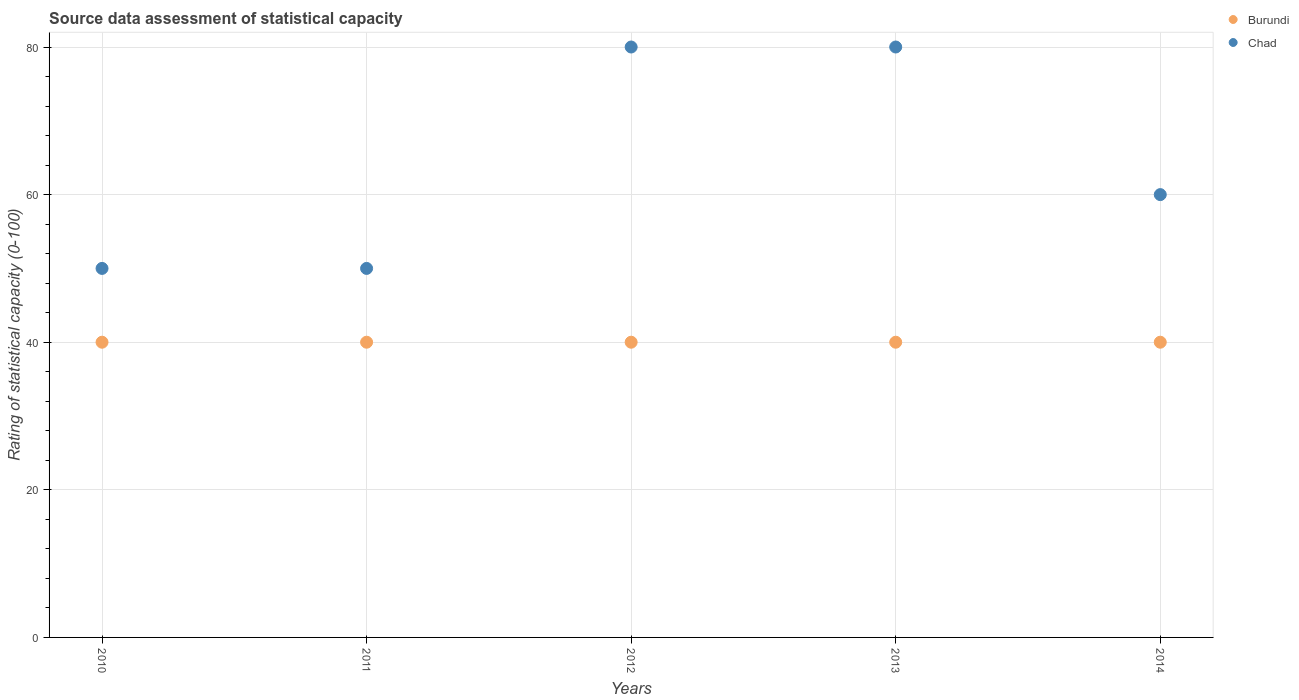How many different coloured dotlines are there?
Your response must be concise. 2. What is the rating of statistical capacity in Burundi in 2013?
Keep it short and to the point. 40. Across all years, what is the maximum rating of statistical capacity in Chad?
Your answer should be compact. 80. Across all years, what is the minimum rating of statistical capacity in Chad?
Provide a short and direct response. 50. In which year was the rating of statistical capacity in Chad minimum?
Your answer should be compact. 2010. What is the total rating of statistical capacity in Burundi in the graph?
Your answer should be compact. 200. What is the difference between the rating of statistical capacity in Chad in 2011 and that in 2014?
Your answer should be very brief. -10. What is the difference between the rating of statistical capacity in Burundi in 2011 and the rating of statistical capacity in Chad in 2010?
Make the answer very short. -10. In the year 2014, what is the difference between the rating of statistical capacity in Burundi and rating of statistical capacity in Chad?
Keep it short and to the point. -20. In how many years, is the rating of statistical capacity in Chad greater than 12?
Your response must be concise. 5. What is the difference between the highest and the lowest rating of statistical capacity in Chad?
Offer a terse response. 30. In how many years, is the rating of statistical capacity in Chad greater than the average rating of statistical capacity in Chad taken over all years?
Offer a terse response. 2. Does the rating of statistical capacity in Burundi monotonically increase over the years?
Keep it short and to the point. No. Is the rating of statistical capacity in Burundi strictly greater than the rating of statistical capacity in Chad over the years?
Your answer should be compact. No. How many dotlines are there?
Give a very brief answer. 2. How many years are there in the graph?
Keep it short and to the point. 5. Does the graph contain grids?
Provide a short and direct response. Yes. How many legend labels are there?
Your answer should be very brief. 2. What is the title of the graph?
Provide a succinct answer. Source data assessment of statistical capacity. Does "Afghanistan" appear as one of the legend labels in the graph?
Keep it short and to the point. No. What is the label or title of the Y-axis?
Provide a succinct answer. Rating of statistical capacity (0-100). What is the Rating of statistical capacity (0-100) of Chad in 2010?
Your answer should be compact. 50. What is the Rating of statistical capacity (0-100) of Burundi in 2011?
Provide a short and direct response. 40. What is the Rating of statistical capacity (0-100) of Chad in 2011?
Offer a terse response. 50. What is the Rating of statistical capacity (0-100) of Burundi in 2012?
Keep it short and to the point. 40. What is the Rating of statistical capacity (0-100) in Burundi in 2013?
Your answer should be very brief. 40. What is the Rating of statistical capacity (0-100) of Chad in 2013?
Offer a terse response. 80. What is the Rating of statistical capacity (0-100) of Burundi in 2014?
Provide a succinct answer. 40. Across all years, what is the maximum Rating of statistical capacity (0-100) of Burundi?
Your answer should be compact. 40. Across all years, what is the maximum Rating of statistical capacity (0-100) in Chad?
Provide a short and direct response. 80. Across all years, what is the minimum Rating of statistical capacity (0-100) of Chad?
Provide a succinct answer. 50. What is the total Rating of statistical capacity (0-100) of Chad in the graph?
Make the answer very short. 320. What is the difference between the Rating of statistical capacity (0-100) in Burundi in 2010 and that in 2011?
Keep it short and to the point. 0. What is the difference between the Rating of statistical capacity (0-100) in Burundi in 2010 and that in 2012?
Your answer should be very brief. 0. What is the difference between the Rating of statistical capacity (0-100) of Burundi in 2010 and that in 2013?
Offer a terse response. 0. What is the difference between the Rating of statistical capacity (0-100) in Chad in 2010 and that in 2013?
Your answer should be compact. -30. What is the difference between the Rating of statistical capacity (0-100) in Chad in 2010 and that in 2014?
Provide a succinct answer. -10. What is the difference between the Rating of statistical capacity (0-100) in Chad in 2011 and that in 2013?
Your answer should be compact. -30. What is the difference between the Rating of statistical capacity (0-100) of Burundi in 2011 and that in 2014?
Keep it short and to the point. 0. What is the difference between the Rating of statistical capacity (0-100) in Chad in 2011 and that in 2014?
Provide a succinct answer. -10. What is the difference between the Rating of statistical capacity (0-100) of Burundi in 2013 and that in 2014?
Your response must be concise. 0. What is the difference between the Rating of statistical capacity (0-100) of Burundi in 2010 and the Rating of statistical capacity (0-100) of Chad in 2011?
Provide a succinct answer. -10. What is the difference between the Rating of statistical capacity (0-100) in Burundi in 2010 and the Rating of statistical capacity (0-100) in Chad in 2012?
Offer a terse response. -40. What is the difference between the Rating of statistical capacity (0-100) of Burundi in 2010 and the Rating of statistical capacity (0-100) of Chad in 2014?
Ensure brevity in your answer.  -20. What is the difference between the Rating of statistical capacity (0-100) in Burundi in 2011 and the Rating of statistical capacity (0-100) in Chad in 2012?
Ensure brevity in your answer.  -40. What is the difference between the Rating of statistical capacity (0-100) in Burundi in 2012 and the Rating of statistical capacity (0-100) in Chad in 2014?
Your answer should be very brief. -20. What is the difference between the Rating of statistical capacity (0-100) of Burundi in 2013 and the Rating of statistical capacity (0-100) of Chad in 2014?
Ensure brevity in your answer.  -20. In the year 2010, what is the difference between the Rating of statistical capacity (0-100) in Burundi and Rating of statistical capacity (0-100) in Chad?
Your answer should be very brief. -10. In the year 2011, what is the difference between the Rating of statistical capacity (0-100) of Burundi and Rating of statistical capacity (0-100) of Chad?
Your answer should be compact. -10. In the year 2012, what is the difference between the Rating of statistical capacity (0-100) of Burundi and Rating of statistical capacity (0-100) of Chad?
Provide a short and direct response. -40. In the year 2013, what is the difference between the Rating of statistical capacity (0-100) of Burundi and Rating of statistical capacity (0-100) of Chad?
Your answer should be very brief. -40. In the year 2014, what is the difference between the Rating of statistical capacity (0-100) in Burundi and Rating of statistical capacity (0-100) in Chad?
Offer a very short reply. -20. What is the ratio of the Rating of statistical capacity (0-100) in Chad in 2010 to that in 2011?
Your answer should be compact. 1. What is the ratio of the Rating of statistical capacity (0-100) in Burundi in 2010 to that in 2013?
Your response must be concise. 1. What is the ratio of the Rating of statistical capacity (0-100) of Burundi in 2010 to that in 2014?
Make the answer very short. 1. What is the ratio of the Rating of statistical capacity (0-100) of Chad in 2010 to that in 2014?
Give a very brief answer. 0.83. What is the ratio of the Rating of statistical capacity (0-100) in Burundi in 2011 to that in 2012?
Make the answer very short. 1. What is the ratio of the Rating of statistical capacity (0-100) in Burundi in 2011 to that in 2013?
Keep it short and to the point. 1. What is the ratio of the Rating of statistical capacity (0-100) in Chad in 2011 to that in 2013?
Offer a terse response. 0.62. What is the ratio of the Rating of statistical capacity (0-100) of Burundi in 2011 to that in 2014?
Give a very brief answer. 1. What is the ratio of the Rating of statistical capacity (0-100) in Burundi in 2012 to that in 2013?
Your response must be concise. 1. What is the ratio of the Rating of statistical capacity (0-100) of Burundi in 2012 to that in 2014?
Your answer should be very brief. 1. What is the ratio of the Rating of statistical capacity (0-100) of Chad in 2012 to that in 2014?
Provide a succinct answer. 1.33. What is the ratio of the Rating of statistical capacity (0-100) in Burundi in 2013 to that in 2014?
Give a very brief answer. 1. What is the ratio of the Rating of statistical capacity (0-100) of Chad in 2013 to that in 2014?
Provide a succinct answer. 1.33. What is the difference between the highest and the lowest Rating of statistical capacity (0-100) in Burundi?
Offer a terse response. 0. 